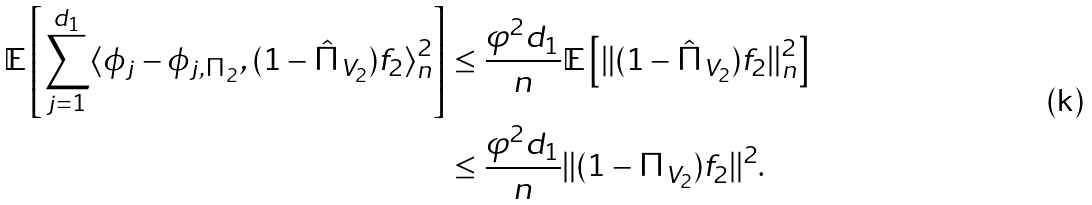<formula> <loc_0><loc_0><loc_500><loc_500>\mathbb { E } \left [ \sum _ { j = 1 } ^ { d _ { 1 } } \langle \phi _ { j } - \phi _ { j , \Pi _ { 2 } } , ( 1 - \hat { \Pi } _ { V _ { 2 } } ) f _ { 2 } \rangle _ { n } ^ { 2 } \right ] & \leq \frac { \varphi ^ { 2 } d _ { 1 } } { n } \mathbb { E } \left [ \| ( 1 - \hat { \Pi } _ { V _ { 2 } } ) f _ { 2 } \| ^ { 2 } _ { n } \right ] \\ & \leq \frac { \varphi ^ { 2 } d _ { 1 } } { n } \| ( 1 - \Pi _ { V _ { 2 } } ) f _ { 2 } \| ^ { 2 } .</formula> 